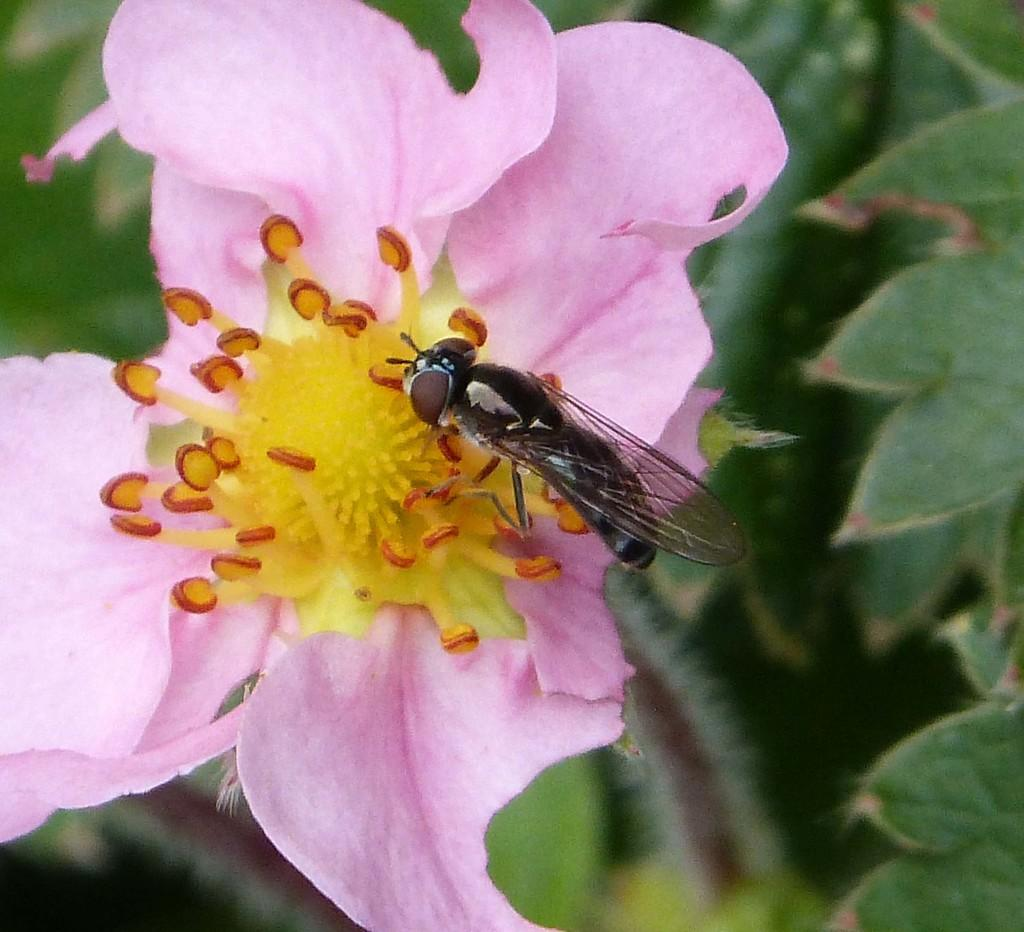What insect is present in the image? There is a house fly in the image. What is the house fly sitting on? The house fly is on a pink color flower. What type of meal is being prepared in the image? There is no meal preparation visible in the image; it only features a house fly on a pink color flower. 